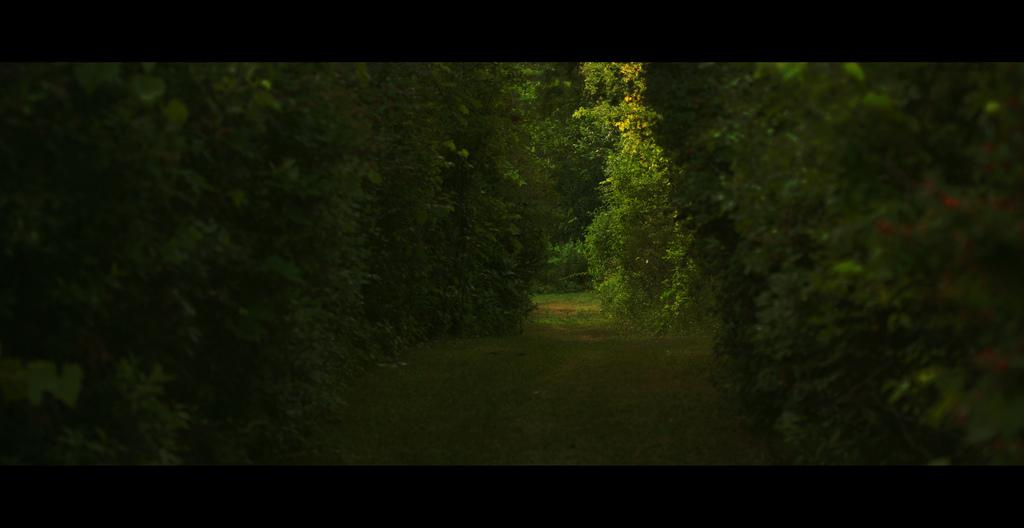What is the main feature in the center of the image? There is a path in the center of the image. What can be seen on the right side of the image? There are trees on the right side of the image. What can be seen on the left side of the image? There are trees on the left side of the image. What is visible in the background of the image? There are trees in the background of the image. What type of cushion is placed on the path in the image? There is no cushion present on the path in the image. 